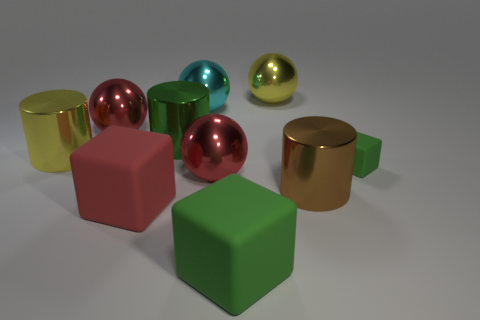How many metal things are either big yellow balls or cyan things?
Your answer should be compact. 2. What size is the other green thing that is the same shape as the big green matte thing?
Keep it short and to the point. Small. There is a yellow shiny cylinder; does it have the same size as the cube to the right of the large yellow ball?
Give a very brief answer. No. The red metal object in front of the small cube has what shape?
Offer a terse response. Sphere. What is the color of the big ball that is to the right of the large thing that is in front of the big red matte cube?
Give a very brief answer. Yellow. There is a small rubber object that is the same shape as the large green rubber object; what is its color?
Offer a terse response. Green. How many large objects have the same color as the tiny cube?
Offer a very short reply. 2. There is a small matte object; is it the same color as the big matte object that is right of the cyan object?
Offer a terse response. Yes. There is a rubber object that is both on the left side of the tiny block and right of the cyan metal ball; what is its shape?
Keep it short and to the point. Cube. There is a large green object that is behind the large yellow metal object that is on the left side of the green rubber thing that is left of the small rubber thing; what is it made of?
Your response must be concise. Metal. 